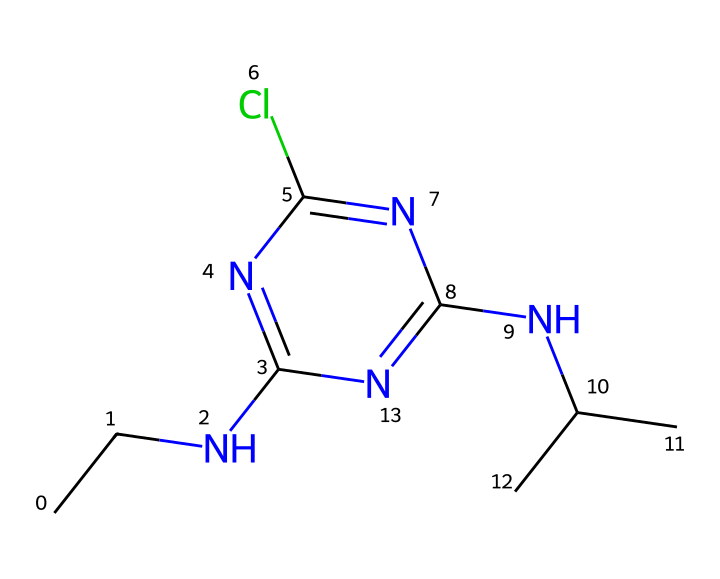What is the primary function of atrazine? Atrazine is primarily used as a herbicide to control weeds in crops, indicating its function as an agricultural chemical.
Answer: herbicide How many chlorine atoms are present in the structure? By examining the SMILES representation, the "Cl" indicates one chlorine atom is present in the molecule.
Answer: one What type of nitrogen atoms are in this herbicide? The presence of “N” in the structure shows nitrogen atoms, and their arrangement indicates one is part of an amine (NC) and the others are part of aromatic rings.
Answer: two amine; one aromatic What is the total number of carbon atoms in atrazine? The "C" symbols in the SMILES show a total of 5 carbon atoms in the branched chain and ring.
Answer: five What does the "C(C)C" part indicate about the structure? The "C(C)C" indicates a branched carbon chain, suggesting the presence of isopropyl groups, which can influence the herbicide's function and solubility.
Answer: isopropyl groups What does the presence of nitrogen atoms imply in atrazine? The nitrogen atoms contribute to the herbicide's mode of action, which often includes disruption of photosynthesis pathways in plants by acting on physiological processes.
Answer: disruption of photosynthesis Which substituent group enhances the herbicide's effectiveness? The chlorine substituent, often present in herbicides, enhances effectiveness by increasing lipophilicity and selectivity in plant uptake, improving herbicidal activity.
Answer: chlorine substituent 